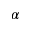<formula> <loc_0><loc_0><loc_500><loc_500>\alpha</formula> 